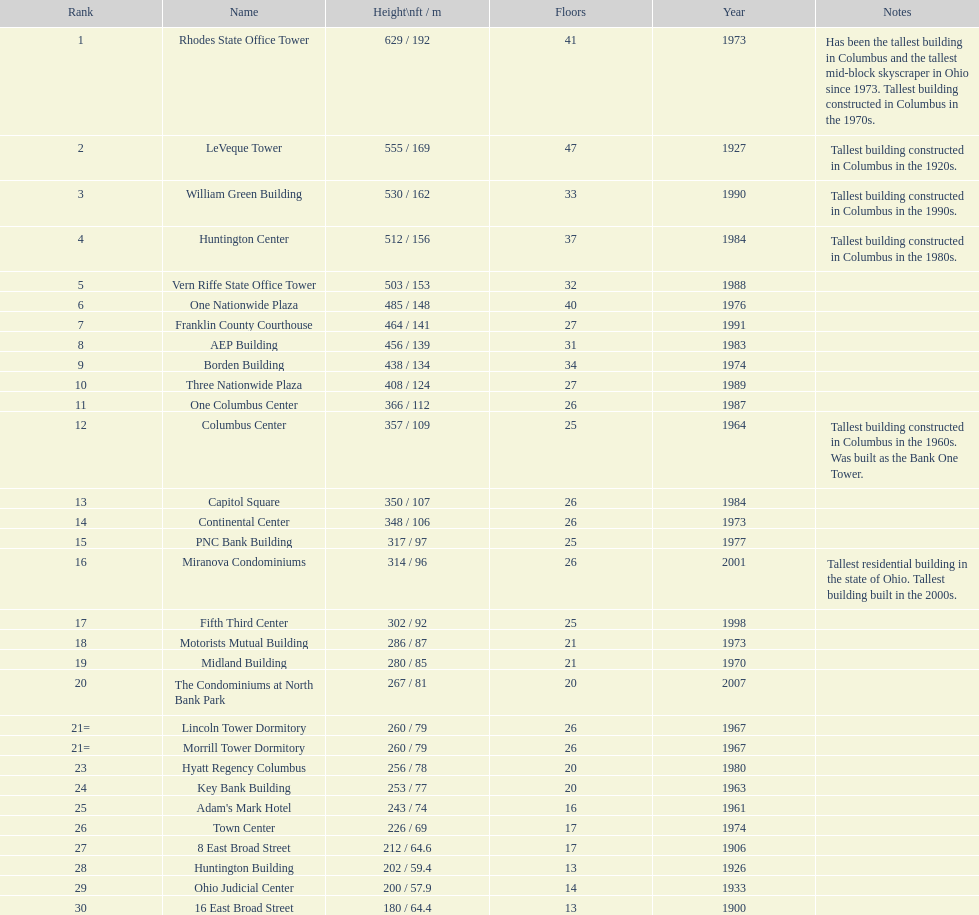Which is the tallest building? Rhodes State Office Tower. 